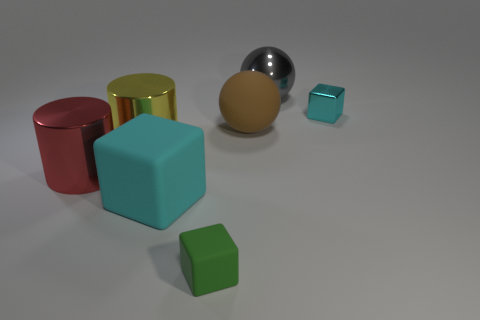Are there more shiny objects that are behind the gray metal ball than metallic cylinders to the left of the large red cylinder? Upon examining the image, it appears there are two shiny objects behind the gray metal ball: a reflective gold cylinder and a small silver cube. To the left of the large red cylinder, there is only one metallic cylinder, which is yellow. Therefore, there are indeed more shiny objects behind the gray ball than metallic cylinders to the left of the large red cylinder. 